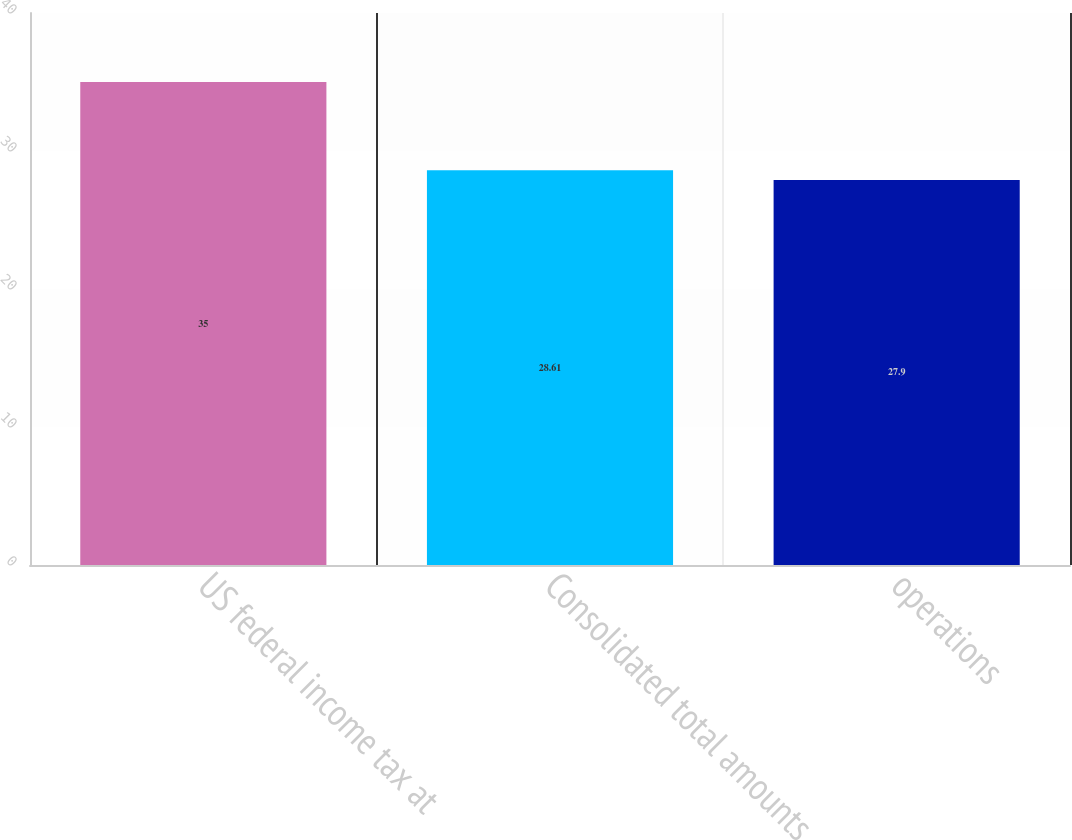Convert chart to OTSL. <chart><loc_0><loc_0><loc_500><loc_500><bar_chart><fcel>US federal income tax at<fcel>Consolidated total amounts<fcel>operations<nl><fcel>35<fcel>28.61<fcel>27.9<nl></chart> 